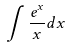Convert formula to latex. <formula><loc_0><loc_0><loc_500><loc_500>\int \frac { e ^ { x } } { x } d x</formula> 